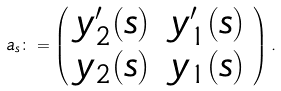<formula> <loc_0><loc_0><loc_500><loc_500>a _ { s } \colon = \left ( \begin{array} { l l } y _ { 2 } ^ { \prime } ( s ) \, & y _ { 1 } ^ { \prime } ( s ) \\ y _ { 2 } ( s ) \, & y _ { 1 } ( s ) \end{array} \right ) .</formula> 